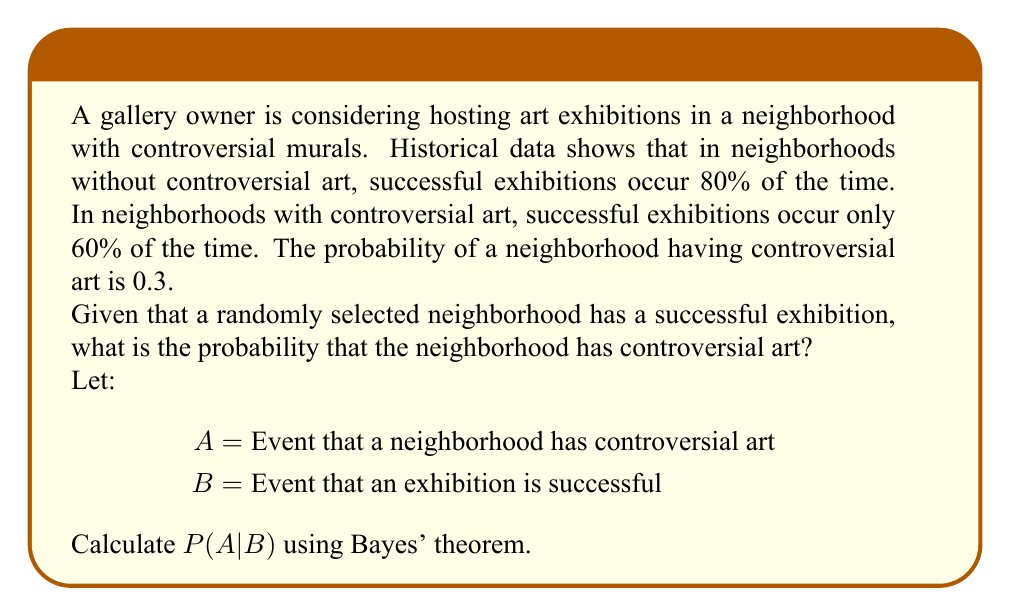Provide a solution to this math problem. To solve this problem, we'll use Bayes' theorem:

$$P(A|B) = \frac{P(B|A)P(A)}{P(B)}$$

Given:
- P(A) = 0.3 (probability of controversial art)
- P(B|A) = 0.6 (probability of success given controversial art)
- P(B|not A) = 0.8 (probability of success given no controversial art)

Step 1: Calculate P(B) using the law of total probability
$$P(B) = P(B|A)P(A) + P(B|not A)P(not A)$$
$$P(B) = 0.6 * 0.3 + 0.8 * 0.7 = 0.18 + 0.56 = 0.74$$

Step 2: Apply Bayes' theorem
$$P(A|B) = \frac{P(B|A)P(A)}{P(B)}$$
$$P(A|B) = \frac{0.6 * 0.3}{0.74}$$
$$P(A|B) = \frac{0.18}{0.74} \approx 0.2432$$

Step 3: Convert to percentage
0.2432 * 100 ≈ 24.32%
Answer: 24.32% 